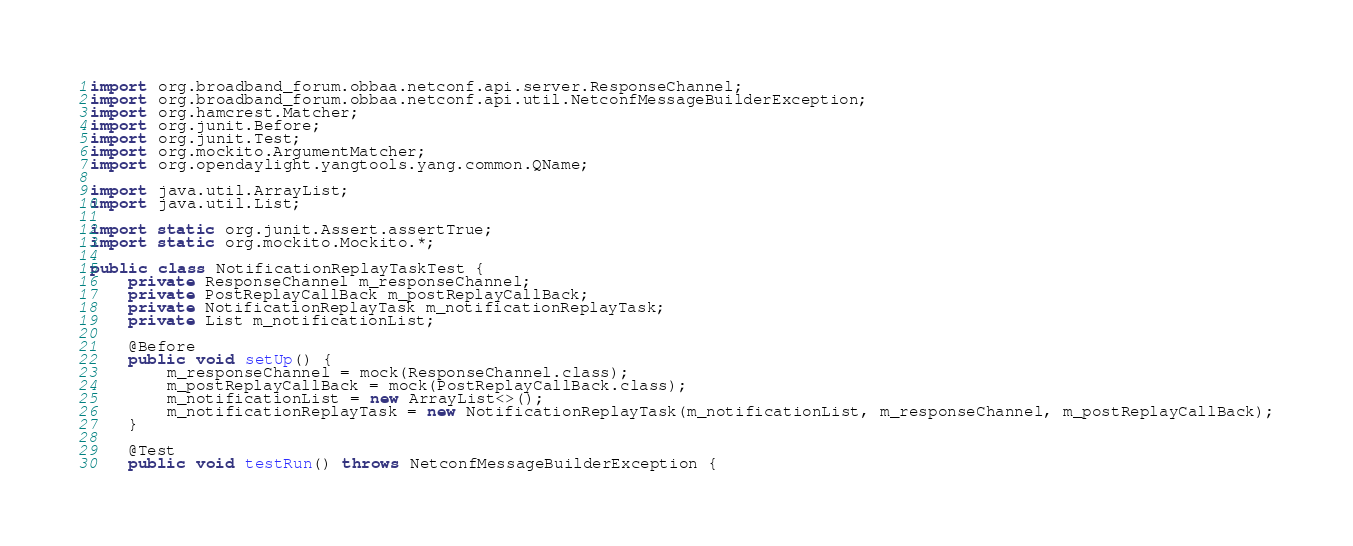Convert code to text. <code><loc_0><loc_0><loc_500><loc_500><_Java_>import org.broadband_forum.obbaa.netconf.api.server.ResponseChannel;
import org.broadband_forum.obbaa.netconf.api.util.NetconfMessageBuilderException;
import org.hamcrest.Matcher;
import org.junit.Before;
import org.junit.Test;
import org.mockito.ArgumentMatcher;
import org.opendaylight.yangtools.yang.common.QName;

import java.util.ArrayList;
import java.util.List;

import static org.junit.Assert.assertTrue;
import static org.mockito.Mockito.*;

public class NotificationReplayTaskTest {
    private ResponseChannel m_responseChannel;
    private PostReplayCallBack m_postReplayCallBack;
    private NotificationReplayTask m_notificationReplayTask;
    private List m_notificationList;

    @Before
    public void setUp() {
        m_responseChannel = mock(ResponseChannel.class);
        m_postReplayCallBack = mock(PostReplayCallBack.class);
        m_notificationList = new ArrayList<>();
        m_notificationReplayTask = new NotificationReplayTask(m_notificationList, m_responseChannel, m_postReplayCallBack);
    }

    @Test
    public void testRun() throws NetconfMessageBuilderException {</code> 